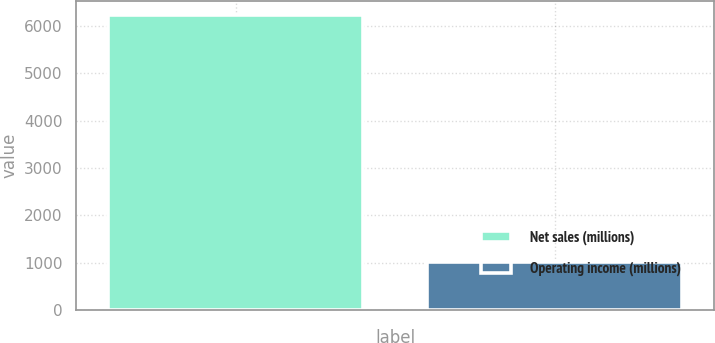Convert chart. <chart><loc_0><loc_0><loc_500><loc_500><bar_chart><fcel>Net sales (millions)<fcel>Operating income (millions)<nl><fcel>6228<fcel>1017<nl></chart> 